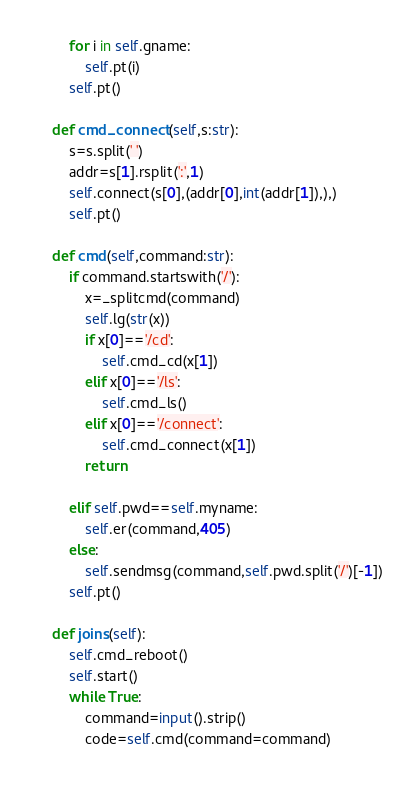Convert code to text. <code><loc_0><loc_0><loc_500><loc_500><_Python_>        for i in self.gname:
            self.pt(i)
        self.pt()

    def cmd_connect(self,s:str):
        s=s.split(' ')
        addr=s[1].rsplit(':',1)
        self.connect(s[0],(addr[0],int(addr[1]),),)
        self.pt()

    def cmd(self,command:str):
        if command.startswith('/'):
            x=_splitcmd(command)
            self.lg(str(x))
            if x[0]=='/cd':
                self.cmd_cd(x[1])
            elif x[0]=='/ls':
                self.cmd_ls()
            elif x[0]=='/connect':
                self.cmd_connect(x[1])
            return

        elif self.pwd==self.myname:
            self.er(command,405)
        else:
            self.sendmsg(command,self.pwd.split('/')[-1])
        self.pt()

    def joins(self):
        self.cmd_reboot()
        self.start()
        while True:
            command=input().strip()
            code=self.cmd(command=command)
</code> 